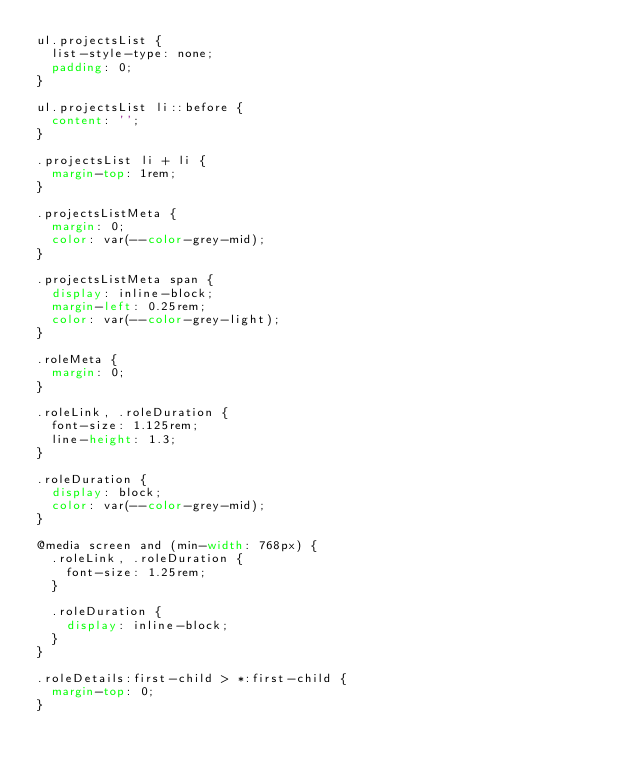<code> <loc_0><loc_0><loc_500><loc_500><_CSS_>ul.projectsList {
  list-style-type: none;
  padding: 0;
}

ul.projectsList li::before {
  content: '';
}

.projectsList li + li {
  margin-top: 1rem;
}

.projectsListMeta {
  margin: 0;
  color: var(--color-grey-mid);
}

.projectsListMeta span {
  display: inline-block;
  margin-left: 0.25rem;
  color: var(--color-grey-light);
}

.roleMeta {
  margin: 0;
}

.roleLink, .roleDuration {
  font-size: 1.125rem;
  line-height: 1.3;
}

.roleDuration {
  display: block;
  color: var(--color-grey-mid);
}

@media screen and (min-width: 768px) {
  .roleLink, .roleDuration {
    font-size: 1.25rem;
  }

  .roleDuration {
    display: inline-block;
  }
}

.roleDetails:first-child > *:first-child {
  margin-top: 0;
}
</code> 